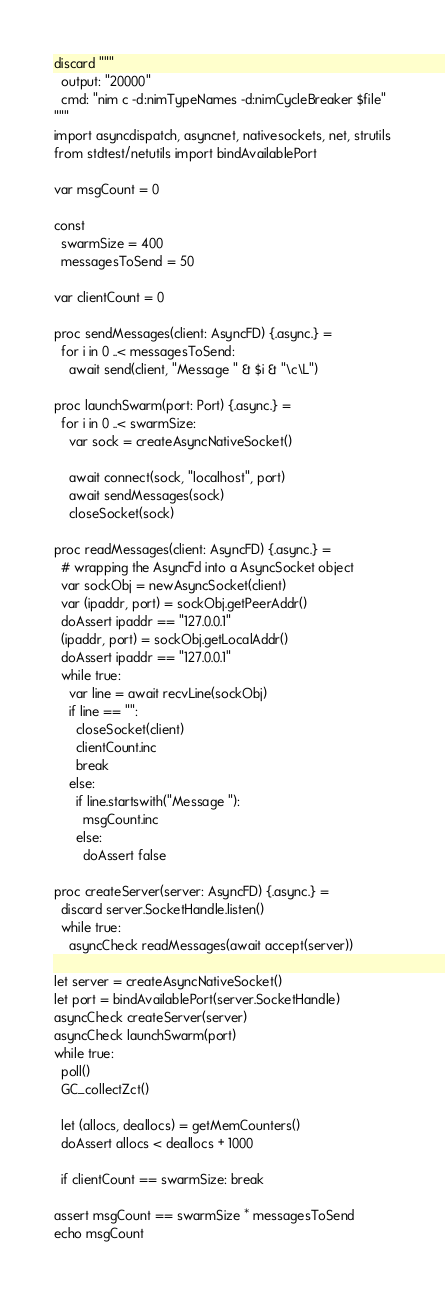<code> <loc_0><loc_0><loc_500><loc_500><_Nim_>discard """
  output: "20000"
  cmd: "nim c -d:nimTypeNames -d:nimCycleBreaker $file"
"""
import asyncdispatch, asyncnet, nativesockets, net, strutils
from stdtest/netutils import bindAvailablePort

var msgCount = 0

const
  swarmSize = 400
  messagesToSend = 50

var clientCount = 0

proc sendMessages(client: AsyncFD) {.async.} =
  for i in 0 ..< messagesToSend:
    await send(client, "Message " & $i & "\c\L")

proc launchSwarm(port: Port) {.async.} =
  for i in 0 ..< swarmSize:
    var sock = createAsyncNativeSocket()

    await connect(sock, "localhost", port)
    await sendMessages(sock)
    closeSocket(sock)

proc readMessages(client: AsyncFD) {.async.} =
  # wrapping the AsyncFd into a AsyncSocket object
  var sockObj = newAsyncSocket(client)
  var (ipaddr, port) = sockObj.getPeerAddr()
  doAssert ipaddr == "127.0.0.1"
  (ipaddr, port) = sockObj.getLocalAddr()
  doAssert ipaddr == "127.0.0.1"
  while true:
    var line = await recvLine(sockObj)
    if line == "":
      closeSocket(client)
      clientCount.inc
      break
    else:
      if line.startswith("Message "):
        msgCount.inc
      else:
        doAssert false

proc createServer(server: AsyncFD) {.async.} =
  discard server.SocketHandle.listen()
  while true:
    asyncCheck readMessages(await accept(server))

let server = createAsyncNativeSocket()
let port = bindAvailablePort(server.SocketHandle)
asyncCheck createServer(server)
asyncCheck launchSwarm(port)
while true:
  poll()
  GC_collectZct()

  let (allocs, deallocs) = getMemCounters()
  doAssert allocs < deallocs + 1000

  if clientCount == swarmSize: break

assert msgCount == swarmSize * messagesToSend
echo msgCount
</code> 